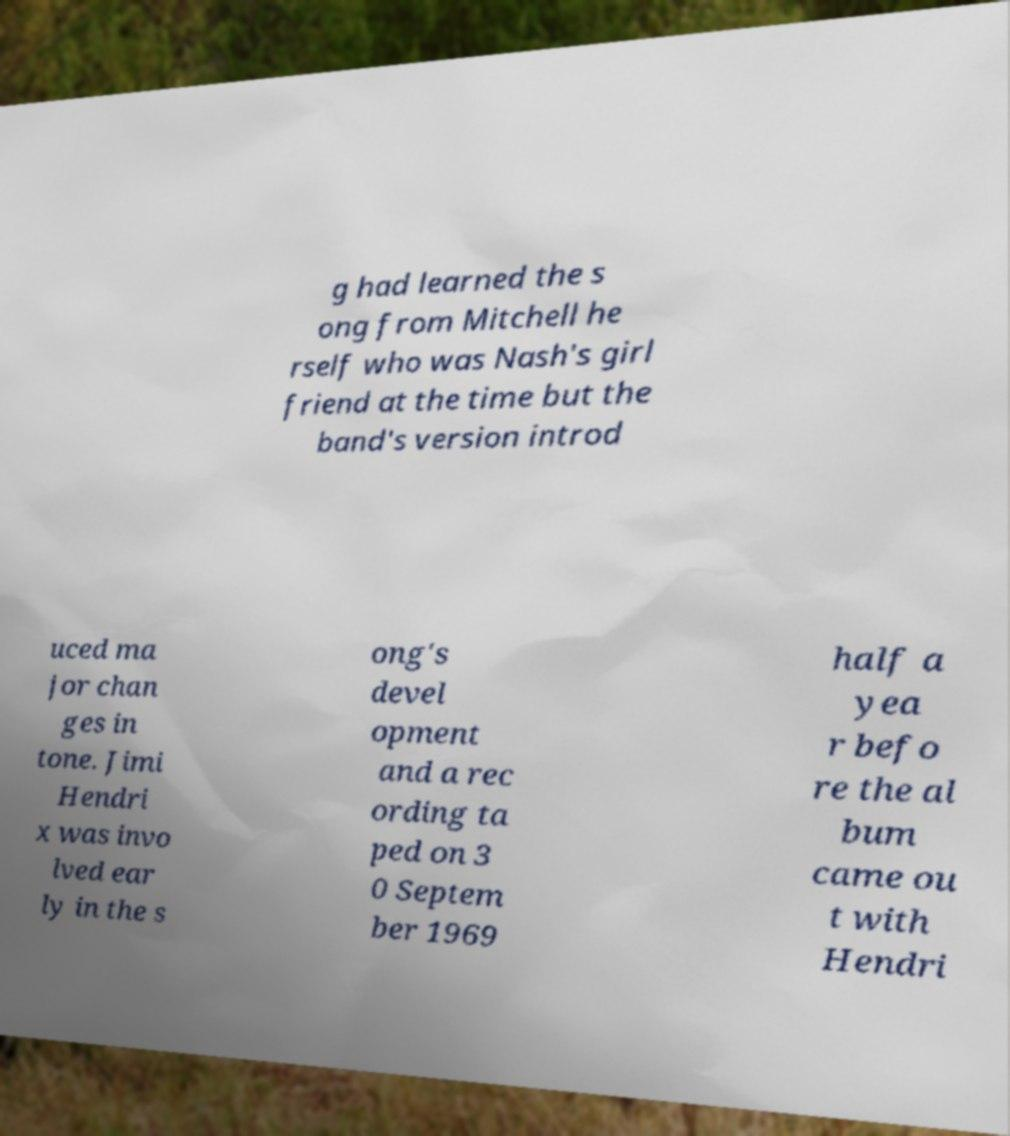Could you extract and type out the text from this image? g had learned the s ong from Mitchell he rself who was Nash's girl friend at the time but the band's version introd uced ma jor chan ges in tone. Jimi Hendri x was invo lved ear ly in the s ong's devel opment and a rec ording ta ped on 3 0 Septem ber 1969 half a yea r befo re the al bum came ou t with Hendri 